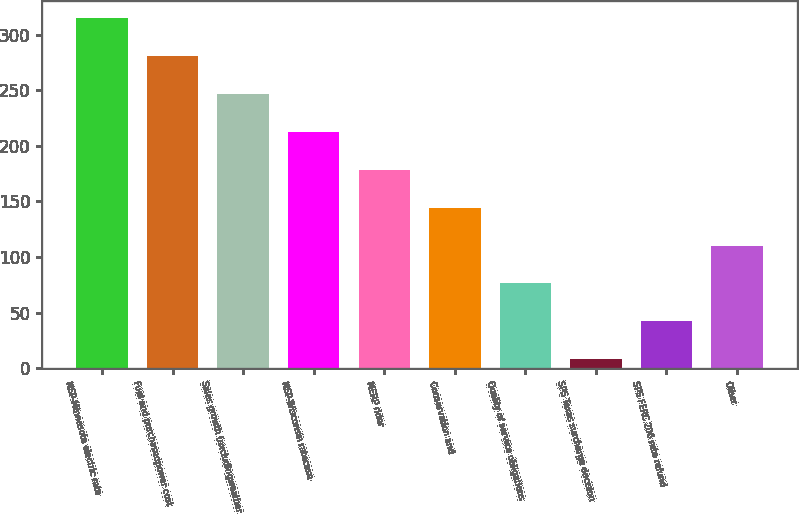Convert chart to OTSL. <chart><loc_0><loc_0><loc_500><loc_500><bar_chart><fcel>NSP-Minnesota electric rate<fcel>Fuel and purchasedpower cost<fcel>Sales growth (excludingweather<fcel>NSP-Wisconsin ratecase<fcel>MERP rider<fcel>Conservation and<fcel>Quality of service obligations<fcel>SPS Texas surcharge decision<fcel>SPS FERC 206 rate refund<fcel>Other<nl><fcel>314.9<fcel>280.8<fcel>246.7<fcel>212.6<fcel>178.5<fcel>144.4<fcel>76.2<fcel>8<fcel>42.1<fcel>110.3<nl></chart> 